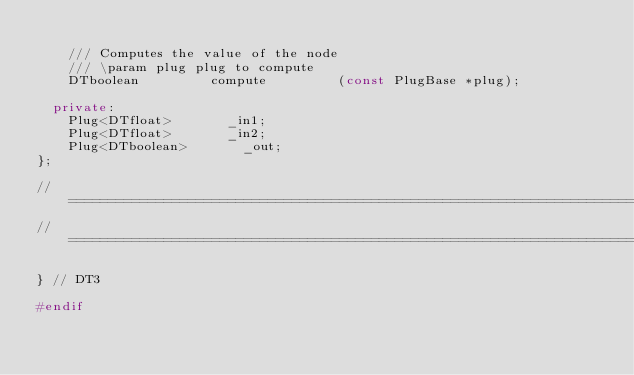Convert code to text. <code><loc_0><loc_0><loc_500><loc_500><_C++_>				
		/// Computes the value of the node
		/// \param plug plug to compute
 		DTboolean					compute					(const PlugBase *plug);

	private:		
		Plug<DTfloat>				_in1;
		Plug<DTfloat>				_in2;
		Plug<DTboolean>				_out;
};

//==============================================================================
//==============================================================================

} // DT3

#endif
</code> 